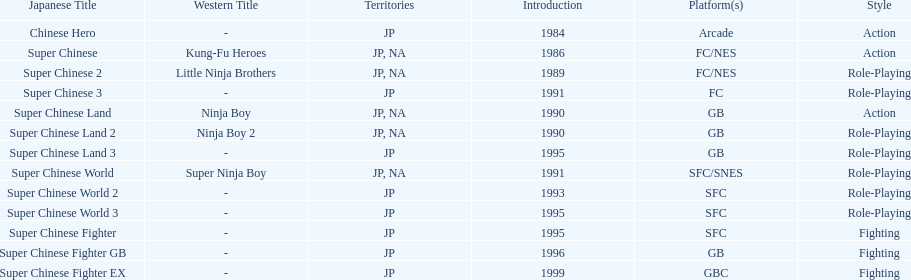Can you parse all the data within this table? {'header': ['Japanese Title', 'Western Title', 'Territories', 'Introduction', 'Platform(s)', 'Style'], 'rows': [['Chinese Hero', '-', 'JP', '1984', 'Arcade', 'Action'], ['Super Chinese', 'Kung-Fu Heroes', 'JP, NA', '1986', 'FC/NES', 'Action'], ['Super Chinese 2', 'Little Ninja Brothers', 'JP, NA', '1989', 'FC/NES', 'Role-Playing'], ['Super Chinese 3', '-', 'JP', '1991', 'FC', 'Role-Playing'], ['Super Chinese Land', 'Ninja Boy', 'JP, NA', '1990', 'GB', 'Action'], ['Super Chinese Land 2', 'Ninja Boy 2', 'JP, NA', '1990', 'GB', 'Role-Playing'], ['Super Chinese Land 3', '-', 'JP', '1995', 'GB', 'Role-Playing'], ['Super Chinese World', 'Super Ninja Boy', 'JP, NA', '1991', 'SFC/SNES', 'Role-Playing'], ['Super Chinese World 2', '-', 'JP', '1993', 'SFC', 'Role-Playing'], ['Super Chinese World 3', '-', 'JP', '1995', 'SFC', 'Role-Playing'], ['Super Chinese Fighter', '-', 'JP', '1995', 'SFC', 'Fighting'], ['Super Chinese Fighter GB', '-', 'JP', '1996', 'GB', 'Fighting'], ['Super Chinese Fighter EX', '-', 'JP', '1999', 'GBC', 'Fighting']]} Number of super chinese world games released 3. 